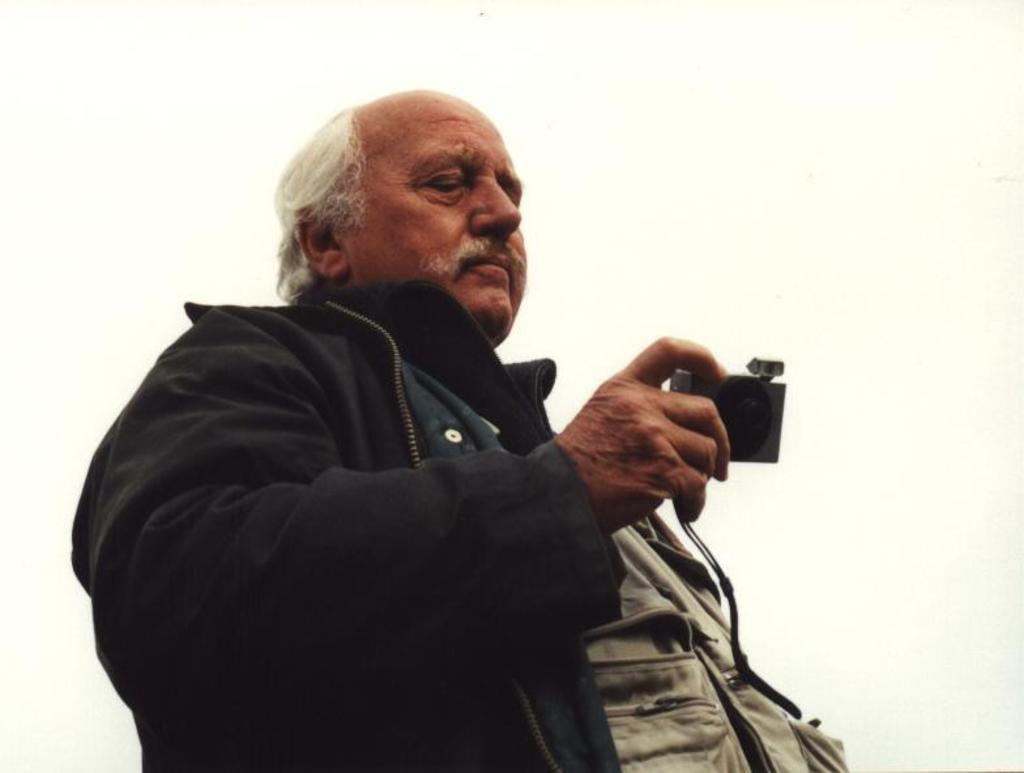Who is the main subject in the image? There is an old man in the image. What is the old man holding in his hand? The old man is holding a camera in his hand. What is the old man wearing in the image? The old man is wearing a black color jacket. Can you see any friction between the old man's shoes and the ground in the image? There is no information about the old man's shoes or the ground in the image, so it is not possible to determine if there is any friction. 